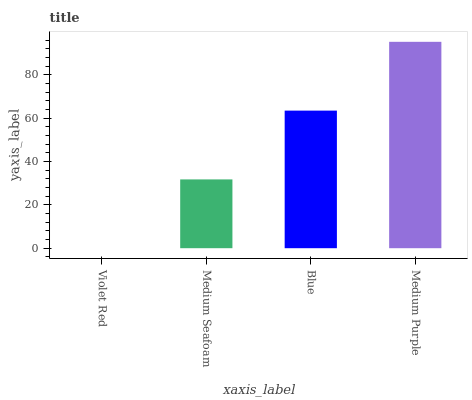Is Violet Red the minimum?
Answer yes or no. Yes. Is Medium Purple the maximum?
Answer yes or no. Yes. Is Medium Seafoam the minimum?
Answer yes or no. No. Is Medium Seafoam the maximum?
Answer yes or no. No. Is Medium Seafoam greater than Violet Red?
Answer yes or no. Yes. Is Violet Red less than Medium Seafoam?
Answer yes or no. Yes. Is Violet Red greater than Medium Seafoam?
Answer yes or no. No. Is Medium Seafoam less than Violet Red?
Answer yes or no. No. Is Blue the high median?
Answer yes or no. Yes. Is Medium Seafoam the low median?
Answer yes or no. Yes. Is Violet Red the high median?
Answer yes or no. No. Is Blue the low median?
Answer yes or no. No. 